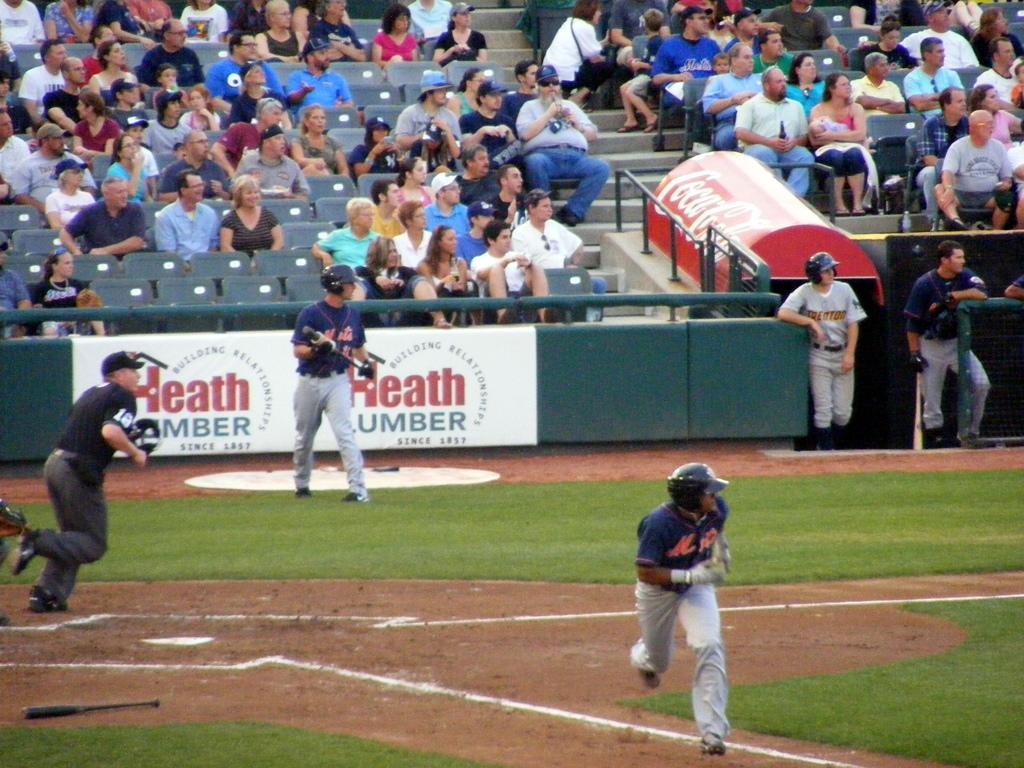<image>
Summarize the visual content of the image. a baseball game happening with a Heath ad 